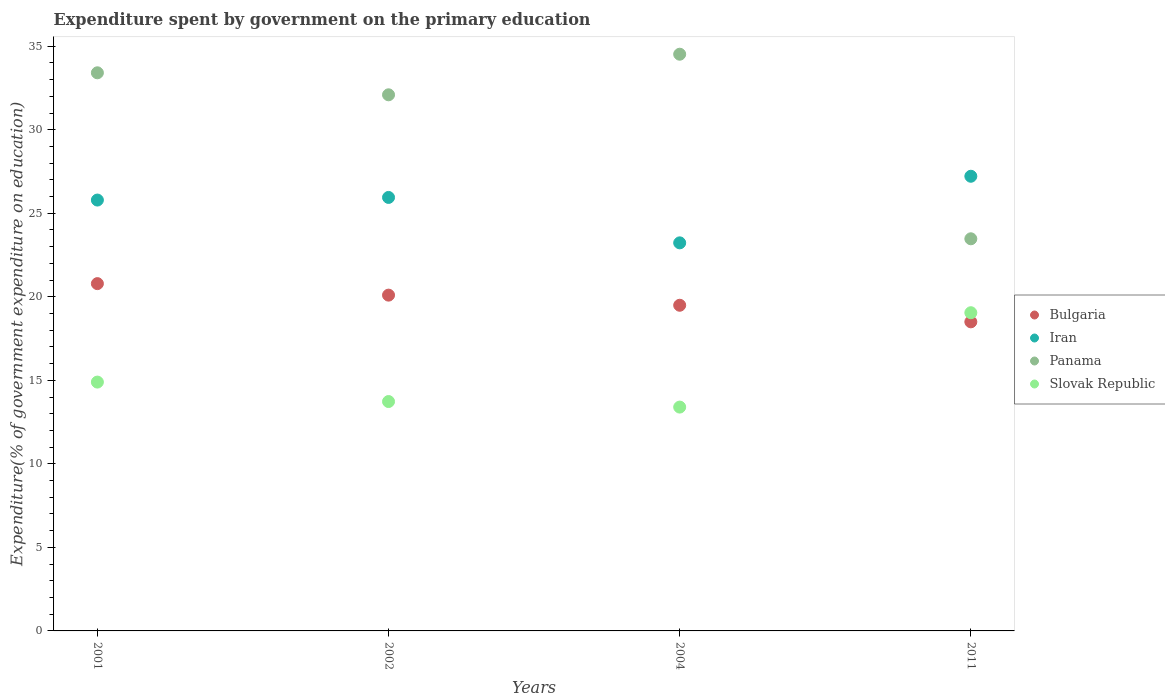How many different coloured dotlines are there?
Provide a succinct answer. 4. Is the number of dotlines equal to the number of legend labels?
Your response must be concise. Yes. What is the expenditure spent by government on the primary education in Panama in 2002?
Make the answer very short. 32.09. Across all years, what is the maximum expenditure spent by government on the primary education in Bulgaria?
Provide a short and direct response. 20.79. Across all years, what is the minimum expenditure spent by government on the primary education in Slovak Republic?
Your answer should be very brief. 13.4. In which year was the expenditure spent by government on the primary education in Panama maximum?
Offer a very short reply. 2004. What is the total expenditure spent by government on the primary education in Bulgaria in the graph?
Give a very brief answer. 78.88. What is the difference between the expenditure spent by government on the primary education in Panama in 2002 and that in 2004?
Make the answer very short. -2.43. What is the difference between the expenditure spent by government on the primary education in Panama in 2002 and the expenditure spent by government on the primary education in Iran in 2001?
Your response must be concise. 6.3. What is the average expenditure spent by government on the primary education in Bulgaria per year?
Offer a very short reply. 19.72. In the year 2002, what is the difference between the expenditure spent by government on the primary education in Panama and expenditure spent by government on the primary education in Bulgaria?
Keep it short and to the point. 11.99. What is the ratio of the expenditure spent by government on the primary education in Bulgaria in 2001 to that in 2011?
Offer a very short reply. 1.12. Is the expenditure spent by government on the primary education in Panama in 2004 less than that in 2011?
Your answer should be compact. No. What is the difference between the highest and the second highest expenditure spent by government on the primary education in Iran?
Provide a short and direct response. 1.27. What is the difference between the highest and the lowest expenditure spent by government on the primary education in Bulgaria?
Offer a terse response. 2.29. In how many years, is the expenditure spent by government on the primary education in Iran greater than the average expenditure spent by government on the primary education in Iran taken over all years?
Provide a succinct answer. 3. Is the sum of the expenditure spent by government on the primary education in Bulgaria in 2002 and 2004 greater than the maximum expenditure spent by government on the primary education in Iran across all years?
Your answer should be compact. Yes. Is it the case that in every year, the sum of the expenditure spent by government on the primary education in Slovak Republic and expenditure spent by government on the primary education in Bulgaria  is greater than the expenditure spent by government on the primary education in Panama?
Provide a succinct answer. No. Is the expenditure spent by government on the primary education in Iran strictly greater than the expenditure spent by government on the primary education in Bulgaria over the years?
Give a very brief answer. Yes. Is the expenditure spent by government on the primary education in Slovak Republic strictly less than the expenditure spent by government on the primary education in Panama over the years?
Ensure brevity in your answer.  Yes. How many dotlines are there?
Offer a terse response. 4. What is the difference between two consecutive major ticks on the Y-axis?
Offer a very short reply. 5. Does the graph contain any zero values?
Make the answer very short. No. Does the graph contain grids?
Provide a short and direct response. No. How many legend labels are there?
Provide a succinct answer. 4. How are the legend labels stacked?
Give a very brief answer. Vertical. What is the title of the graph?
Make the answer very short. Expenditure spent by government on the primary education. Does "St. Vincent and the Grenadines" appear as one of the legend labels in the graph?
Your answer should be compact. No. What is the label or title of the X-axis?
Offer a very short reply. Years. What is the label or title of the Y-axis?
Provide a succinct answer. Expenditure(% of government expenditure on education). What is the Expenditure(% of government expenditure on education) in Bulgaria in 2001?
Provide a succinct answer. 20.79. What is the Expenditure(% of government expenditure on education) in Iran in 2001?
Provide a short and direct response. 25.79. What is the Expenditure(% of government expenditure on education) of Panama in 2001?
Give a very brief answer. 33.41. What is the Expenditure(% of government expenditure on education) of Slovak Republic in 2001?
Make the answer very short. 14.89. What is the Expenditure(% of government expenditure on education) of Bulgaria in 2002?
Offer a terse response. 20.1. What is the Expenditure(% of government expenditure on education) in Iran in 2002?
Keep it short and to the point. 25.95. What is the Expenditure(% of government expenditure on education) of Panama in 2002?
Your answer should be very brief. 32.09. What is the Expenditure(% of government expenditure on education) in Slovak Republic in 2002?
Ensure brevity in your answer.  13.73. What is the Expenditure(% of government expenditure on education) of Bulgaria in 2004?
Give a very brief answer. 19.49. What is the Expenditure(% of government expenditure on education) of Iran in 2004?
Ensure brevity in your answer.  23.23. What is the Expenditure(% of government expenditure on education) of Panama in 2004?
Offer a terse response. 34.52. What is the Expenditure(% of government expenditure on education) in Slovak Republic in 2004?
Give a very brief answer. 13.4. What is the Expenditure(% of government expenditure on education) in Bulgaria in 2011?
Ensure brevity in your answer.  18.5. What is the Expenditure(% of government expenditure on education) of Iran in 2011?
Keep it short and to the point. 27.21. What is the Expenditure(% of government expenditure on education) of Panama in 2011?
Your answer should be very brief. 23.47. What is the Expenditure(% of government expenditure on education) of Slovak Republic in 2011?
Your response must be concise. 19.05. Across all years, what is the maximum Expenditure(% of government expenditure on education) of Bulgaria?
Give a very brief answer. 20.79. Across all years, what is the maximum Expenditure(% of government expenditure on education) in Iran?
Offer a very short reply. 27.21. Across all years, what is the maximum Expenditure(% of government expenditure on education) of Panama?
Make the answer very short. 34.52. Across all years, what is the maximum Expenditure(% of government expenditure on education) in Slovak Republic?
Keep it short and to the point. 19.05. Across all years, what is the minimum Expenditure(% of government expenditure on education) of Bulgaria?
Give a very brief answer. 18.5. Across all years, what is the minimum Expenditure(% of government expenditure on education) in Iran?
Give a very brief answer. 23.23. Across all years, what is the minimum Expenditure(% of government expenditure on education) of Panama?
Provide a short and direct response. 23.47. Across all years, what is the minimum Expenditure(% of government expenditure on education) in Slovak Republic?
Offer a terse response. 13.4. What is the total Expenditure(% of government expenditure on education) of Bulgaria in the graph?
Your answer should be compact. 78.88. What is the total Expenditure(% of government expenditure on education) of Iran in the graph?
Offer a terse response. 102.18. What is the total Expenditure(% of government expenditure on education) of Panama in the graph?
Offer a terse response. 123.49. What is the total Expenditure(% of government expenditure on education) in Slovak Republic in the graph?
Offer a very short reply. 61.07. What is the difference between the Expenditure(% of government expenditure on education) of Bulgaria in 2001 and that in 2002?
Provide a short and direct response. 0.69. What is the difference between the Expenditure(% of government expenditure on education) in Iran in 2001 and that in 2002?
Offer a very short reply. -0.16. What is the difference between the Expenditure(% of government expenditure on education) of Panama in 2001 and that in 2002?
Provide a short and direct response. 1.32. What is the difference between the Expenditure(% of government expenditure on education) of Slovak Republic in 2001 and that in 2002?
Your answer should be compact. 1.16. What is the difference between the Expenditure(% of government expenditure on education) in Bulgaria in 2001 and that in 2004?
Give a very brief answer. 1.29. What is the difference between the Expenditure(% of government expenditure on education) in Iran in 2001 and that in 2004?
Keep it short and to the point. 2.56. What is the difference between the Expenditure(% of government expenditure on education) of Panama in 2001 and that in 2004?
Your answer should be very brief. -1.11. What is the difference between the Expenditure(% of government expenditure on education) of Slovak Republic in 2001 and that in 2004?
Make the answer very short. 1.5. What is the difference between the Expenditure(% of government expenditure on education) of Bulgaria in 2001 and that in 2011?
Provide a short and direct response. 2.29. What is the difference between the Expenditure(% of government expenditure on education) in Iran in 2001 and that in 2011?
Your answer should be compact. -1.42. What is the difference between the Expenditure(% of government expenditure on education) of Panama in 2001 and that in 2011?
Ensure brevity in your answer.  9.94. What is the difference between the Expenditure(% of government expenditure on education) in Slovak Republic in 2001 and that in 2011?
Keep it short and to the point. -4.15. What is the difference between the Expenditure(% of government expenditure on education) of Bulgaria in 2002 and that in 2004?
Your answer should be compact. 0.61. What is the difference between the Expenditure(% of government expenditure on education) of Iran in 2002 and that in 2004?
Your response must be concise. 2.72. What is the difference between the Expenditure(% of government expenditure on education) in Panama in 2002 and that in 2004?
Provide a succinct answer. -2.43. What is the difference between the Expenditure(% of government expenditure on education) of Slovak Republic in 2002 and that in 2004?
Provide a short and direct response. 0.33. What is the difference between the Expenditure(% of government expenditure on education) of Bulgaria in 2002 and that in 2011?
Offer a very short reply. 1.6. What is the difference between the Expenditure(% of government expenditure on education) in Iran in 2002 and that in 2011?
Make the answer very short. -1.27. What is the difference between the Expenditure(% of government expenditure on education) of Panama in 2002 and that in 2011?
Your answer should be very brief. 8.62. What is the difference between the Expenditure(% of government expenditure on education) in Slovak Republic in 2002 and that in 2011?
Offer a terse response. -5.32. What is the difference between the Expenditure(% of government expenditure on education) of Iran in 2004 and that in 2011?
Make the answer very short. -3.99. What is the difference between the Expenditure(% of government expenditure on education) of Panama in 2004 and that in 2011?
Provide a succinct answer. 11.05. What is the difference between the Expenditure(% of government expenditure on education) in Slovak Republic in 2004 and that in 2011?
Make the answer very short. -5.65. What is the difference between the Expenditure(% of government expenditure on education) of Bulgaria in 2001 and the Expenditure(% of government expenditure on education) of Iran in 2002?
Offer a terse response. -5.16. What is the difference between the Expenditure(% of government expenditure on education) in Bulgaria in 2001 and the Expenditure(% of government expenditure on education) in Panama in 2002?
Give a very brief answer. -11.3. What is the difference between the Expenditure(% of government expenditure on education) of Bulgaria in 2001 and the Expenditure(% of government expenditure on education) of Slovak Republic in 2002?
Keep it short and to the point. 7.06. What is the difference between the Expenditure(% of government expenditure on education) of Iran in 2001 and the Expenditure(% of government expenditure on education) of Panama in 2002?
Your response must be concise. -6.3. What is the difference between the Expenditure(% of government expenditure on education) in Iran in 2001 and the Expenditure(% of government expenditure on education) in Slovak Republic in 2002?
Your answer should be very brief. 12.06. What is the difference between the Expenditure(% of government expenditure on education) of Panama in 2001 and the Expenditure(% of government expenditure on education) of Slovak Republic in 2002?
Ensure brevity in your answer.  19.68. What is the difference between the Expenditure(% of government expenditure on education) in Bulgaria in 2001 and the Expenditure(% of government expenditure on education) in Iran in 2004?
Provide a succinct answer. -2.44. What is the difference between the Expenditure(% of government expenditure on education) of Bulgaria in 2001 and the Expenditure(% of government expenditure on education) of Panama in 2004?
Keep it short and to the point. -13.73. What is the difference between the Expenditure(% of government expenditure on education) in Bulgaria in 2001 and the Expenditure(% of government expenditure on education) in Slovak Republic in 2004?
Offer a terse response. 7.39. What is the difference between the Expenditure(% of government expenditure on education) in Iran in 2001 and the Expenditure(% of government expenditure on education) in Panama in 2004?
Provide a succinct answer. -8.73. What is the difference between the Expenditure(% of government expenditure on education) of Iran in 2001 and the Expenditure(% of government expenditure on education) of Slovak Republic in 2004?
Offer a terse response. 12.39. What is the difference between the Expenditure(% of government expenditure on education) in Panama in 2001 and the Expenditure(% of government expenditure on education) in Slovak Republic in 2004?
Your answer should be very brief. 20.01. What is the difference between the Expenditure(% of government expenditure on education) of Bulgaria in 2001 and the Expenditure(% of government expenditure on education) of Iran in 2011?
Make the answer very short. -6.43. What is the difference between the Expenditure(% of government expenditure on education) of Bulgaria in 2001 and the Expenditure(% of government expenditure on education) of Panama in 2011?
Your response must be concise. -2.68. What is the difference between the Expenditure(% of government expenditure on education) of Bulgaria in 2001 and the Expenditure(% of government expenditure on education) of Slovak Republic in 2011?
Provide a succinct answer. 1.74. What is the difference between the Expenditure(% of government expenditure on education) of Iran in 2001 and the Expenditure(% of government expenditure on education) of Panama in 2011?
Offer a terse response. 2.32. What is the difference between the Expenditure(% of government expenditure on education) in Iran in 2001 and the Expenditure(% of government expenditure on education) in Slovak Republic in 2011?
Ensure brevity in your answer.  6.74. What is the difference between the Expenditure(% of government expenditure on education) in Panama in 2001 and the Expenditure(% of government expenditure on education) in Slovak Republic in 2011?
Give a very brief answer. 14.36. What is the difference between the Expenditure(% of government expenditure on education) in Bulgaria in 2002 and the Expenditure(% of government expenditure on education) in Iran in 2004?
Provide a short and direct response. -3.13. What is the difference between the Expenditure(% of government expenditure on education) of Bulgaria in 2002 and the Expenditure(% of government expenditure on education) of Panama in 2004?
Offer a terse response. -14.42. What is the difference between the Expenditure(% of government expenditure on education) of Bulgaria in 2002 and the Expenditure(% of government expenditure on education) of Slovak Republic in 2004?
Keep it short and to the point. 6.7. What is the difference between the Expenditure(% of government expenditure on education) of Iran in 2002 and the Expenditure(% of government expenditure on education) of Panama in 2004?
Your response must be concise. -8.57. What is the difference between the Expenditure(% of government expenditure on education) of Iran in 2002 and the Expenditure(% of government expenditure on education) of Slovak Republic in 2004?
Your answer should be very brief. 12.55. What is the difference between the Expenditure(% of government expenditure on education) of Panama in 2002 and the Expenditure(% of government expenditure on education) of Slovak Republic in 2004?
Provide a succinct answer. 18.69. What is the difference between the Expenditure(% of government expenditure on education) of Bulgaria in 2002 and the Expenditure(% of government expenditure on education) of Iran in 2011?
Your answer should be very brief. -7.12. What is the difference between the Expenditure(% of government expenditure on education) in Bulgaria in 2002 and the Expenditure(% of government expenditure on education) in Panama in 2011?
Your answer should be very brief. -3.37. What is the difference between the Expenditure(% of government expenditure on education) of Bulgaria in 2002 and the Expenditure(% of government expenditure on education) of Slovak Republic in 2011?
Provide a short and direct response. 1.05. What is the difference between the Expenditure(% of government expenditure on education) of Iran in 2002 and the Expenditure(% of government expenditure on education) of Panama in 2011?
Ensure brevity in your answer.  2.48. What is the difference between the Expenditure(% of government expenditure on education) in Iran in 2002 and the Expenditure(% of government expenditure on education) in Slovak Republic in 2011?
Offer a very short reply. 6.9. What is the difference between the Expenditure(% of government expenditure on education) of Panama in 2002 and the Expenditure(% of government expenditure on education) of Slovak Republic in 2011?
Offer a terse response. 13.04. What is the difference between the Expenditure(% of government expenditure on education) of Bulgaria in 2004 and the Expenditure(% of government expenditure on education) of Iran in 2011?
Provide a succinct answer. -7.72. What is the difference between the Expenditure(% of government expenditure on education) of Bulgaria in 2004 and the Expenditure(% of government expenditure on education) of Panama in 2011?
Offer a very short reply. -3.98. What is the difference between the Expenditure(% of government expenditure on education) of Bulgaria in 2004 and the Expenditure(% of government expenditure on education) of Slovak Republic in 2011?
Ensure brevity in your answer.  0.45. What is the difference between the Expenditure(% of government expenditure on education) of Iran in 2004 and the Expenditure(% of government expenditure on education) of Panama in 2011?
Offer a terse response. -0.24. What is the difference between the Expenditure(% of government expenditure on education) in Iran in 2004 and the Expenditure(% of government expenditure on education) in Slovak Republic in 2011?
Ensure brevity in your answer.  4.18. What is the difference between the Expenditure(% of government expenditure on education) in Panama in 2004 and the Expenditure(% of government expenditure on education) in Slovak Republic in 2011?
Give a very brief answer. 15.47. What is the average Expenditure(% of government expenditure on education) in Bulgaria per year?
Keep it short and to the point. 19.72. What is the average Expenditure(% of government expenditure on education) of Iran per year?
Make the answer very short. 25.54. What is the average Expenditure(% of government expenditure on education) in Panama per year?
Ensure brevity in your answer.  30.87. What is the average Expenditure(% of government expenditure on education) in Slovak Republic per year?
Give a very brief answer. 15.27. In the year 2001, what is the difference between the Expenditure(% of government expenditure on education) in Bulgaria and Expenditure(% of government expenditure on education) in Iran?
Provide a short and direct response. -5. In the year 2001, what is the difference between the Expenditure(% of government expenditure on education) in Bulgaria and Expenditure(% of government expenditure on education) in Panama?
Offer a terse response. -12.62. In the year 2001, what is the difference between the Expenditure(% of government expenditure on education) of Bulgaria and Expenditure(% of government expenditure on education) of Slovak Republic?
Your response must be concise. 5.89. In the year 2001, what is the difference between the Expenditure(% of government expenditure on education) of Iran and Expenditure(% of government expenditure on education) of Panama?
Provide a short and direct response. -7.62. In the year 2001, what is the difference between the Expenditure(% of government expenditure on education) in Iran and Expenditure(% of government expenditure on education) in Slovak Republic?
Your answer should be compact. 10.9. In the year 2001, what is the difference between the Expenditure(% of government expenditure on education) in Panama and Expenditure(% of government expenditure on education) in Slovak Republic?
Your answer should be very brief. 18.51. In the year 2002, what is the difference between the Expenditure(% of government expenditure on education) of Bulgaria and Expenditure(% of government expenditure on education) of Iran?
Provide a short and direct response. -5.85. In the year 2002, what is the difference between the Expenditure(% of government expenditure on education) in Bulgaria and Expenditure(% of government expenditure on education) in Panama?
Your response must be concise. -11.99. In the year 2002, what is the difference between the Expenditure(% of government expenditure on education) in Bulgaria and Expenditure(% of government expenditure on education) in Slovak Republic?
Offer a very short reply. 6.37. In the year 2002, what is the difference between the Expenditure(% of government expenditure on education) of Iran and Expenditure(% of government expenditure on education) of Panama?
Keep it short and to the point. -6.14. In the year 2002, what is the difference between the Expenditure(% of government expenditure on education) of Iran and Expenditure(% of government expenditure on education) of Slovak Republic?
Offer a very short reply. 12.22. In the year 2002, what is the difference between the Expenditure(% of government expenditure on education) in Panama and Expenditure(% of government expenditure on education) in Slovak Republic?
Make the answer very short. 18.36. In the year 2004, what is the difference between the Expenditure(% of government expenditure on education) in Bulgaria and Expenditure(% of government expenditure on education) in Iran?
Offer a very short reply. -3.74. In the year 2004, what is the difference between the Expenditure(% of government expenditure on education) in Bulgaria and Expenditure(% of government expenditure on education) in Panama?
Your answer should be very brief. -15.03. In the year 2004, what is the difference between the Expenditure(% of government expenditure on education) in Bulgaria and Expenditure(% of government expenditure on education) in Slovak Republic?
Your answer should be very brief. 6.09. In the year 2004, what is the difference between the Expenditure(% of government expenditure on education) of Iran and Expenditure(% of government expenditure on education) of Panama?
Offer a very short reply. -11.29. In the year 2004, what is the difference between the Expenditure(% of government expenditure on education) in Iran and Expenditure(% of government expenditure on education) in Slovak Republic?
Your answer should be compact. 9.83. In the year 2004, what is the difference between the Expenditure(% of government expenditure on education) in Panama and Expenditure(% of government expenditure on education) in Slovak Republic?
Your answer should be very brief. 21.12. In the year 2011, what is the difference between the Expenditure(% of government expenditure on education) in Bulgaria and Expenditure(% of government expenditure on education) in Iran?
Provide a succinct answer. -8.71. In the year 2011, what is the difference between the Expenditure(% of government expenditure on education) in Bulgaria and Expenditure(% of government expenditure on education) in Panama?
Your answer should be compact. -4.97. In the year 2011, what is the difference between the Expenditure(% of government expenditure on education) in Bulgaria and Expenditure(% of government expenditure on education) in Slovak Republic?
Make the answer very short. -0.55. In the year 2011, what is the difference between the Expenditure(% of government expenditure on education) in Iran and Expenditure(% of government expenditure on education) in Panama?
Provide a succinct answer. 3.74. In the year 2011, what is the difference between the Expenditure(% of government expenditure on education) of Iran and Expenditure(% of government expenditure on education) of Slovak Republic?
Offer a very short reply. 8.17. In the year 2011, what is the difference between the Expenditure(% of government expenditure on education) in Panama and Expenditure(% of government expenditure on education) in Slovak Republic?
Your answer should be very brief. 4.43. What is the ratio of the Expenditure(% of government expenditure on education) in Bulgaria in 2001 to that in 2002?
Your answer should be very brief. 1.03. What is the ratio of the Expenditure(% of government expenditure on education) in Iran in 2001 to that in 2002?
Your response must be concise. 0.99. What is the ratio of the Expenditure(% of government expenditure on education) of Panama in 2001 to that in 2002?
Keep it short and to the point. 1.04. What is the ratio of the Expenditure(% of government expenditure on education) of Slovak Republic in 2001 to that in 2002?
Your response must be concise. 1.08. What is the ratio of the Expenditure(% of government expenditure on education) in Bulgaria in 2001 to that in 2004?
Make the answer very short. 1.07. What is the ratio of the Expenditure(% of government expenditure on education) in Iran in 2001 to that in 2004?
Provide a succinct answer. 1.11. What is the ratio of the Expenditure(% of government expenditure on education) of Panama in 2001 to that in 2004?
Offer a very short reply. 0.97. What is the ratio of the Expenditure(% of government expenditure on education) of Slovak Republic in 2001 to that in 2004?
Ensure brevity in your answer.  1.11. What is the ratio of the Expenditure(% of government expenditure on education) in Bulgaria in 2001 to that in 2011?
Provide a short and direct response. 1.12. What is the ratio of the Expenditure(% of government expenditure on education) of Iran in 2001 to that in 2011?
Your answer should be very brief. 0.95. What is the ratio of the Expenditure(% of government expenditure on education) of Panama in 2001 to that in 2011?
Provide a succinct answer. 1.42. What is the ratio of the Expenditure(% of government expenditure on education) of Slovak Republic in 2001 to that in 2011?
Offer a very short reply. 0.78. What is the ratio of the Expenditure(% of government expenditure on education) in Bulgaria in 2002 to that in 2004?
Ensure brevity in your answer.  1.03. What is the ratio of the Expenditure(% of government expenditure on education) in Iran in 2002 to that in 2004?
Provide a succinct answer. 1.12. What is the ratio of the Expenditure(% of government expenditure on education) of Panama in 2002 to that in 2004?
Offer a terse response. 0.93. What is the ratio of the Expenditure(% of government expenditure on education) of Slovak Republic in 2002 to that in 2004?
Ensure brevity in your answer.  1.02. What is the ratio of the Expenditure(% of government expenditure on education) in Bulgaria in 2002 to that in 2011?
Your answer should be compact. 1.09. What is the ratio of the Expenditure(% of government expenditure on education) of Iran in 2002 to that in 2011?
Your answer should be compact. 0.95. What is the ratio of the Expenditure(% of government expenditure on education) of Panama in 2002 to that in 2011?
Ensure brevity in your answer.  1.37. What is the ratio of the Expenditure(% of government expenditure on education) of Slovak Republic in 2002 to that in 2011?
Your answer should be compact. 0.72. What is the ratio of the Expenditure(% of government expenditure on education) of Bulgaria in 2004 to that in 2011?
Offer a very short reply. 1.05. What is the ratio of the Expenditure(% of government expenditure on education) of Iran in 2004 to that in 2011?
Offer a terse response. 0.85. What is the ratio of the Expenditure(% of government expenditure on education) of Panama in 2004 to that in 2011?
Give a very brief answer. 1.47. What is the ratio of the Expenditure(% of government expenditure on education) of Slovak Republic in 2004 to that in 2011?
Keep it short and to the point. 0.7. What is the difference between the highest and the second highest Expenditure(% of government expenditure on education) in Bulgaria?
Offer a terse response. 0.69. What is the difference between the highest and the second highest Expenditure(% of government expenditure on education) of Iran?
Your response must be concise. 1.27. What is the difference between the highest and the second highest Expenditure(% of government expenditure on education) of Panama?
Offer a terse response. 1.11. What is the difference between the highest and the second highest Expenditure(% of government expenditure on education) in Slovak Republic?
Provide a short and direct response. 4.15. What is the difference between the highest and the lowest Expenditure(% of government expenditure on education) of Bulgaria?
Make the answer very short. 2.29. What is the difference between the highest and the lowest Expenditure(% of government expenditure on education) in Iran?
Keep it short and to the point. 3.99. What is the difference between the highest and the lowest Expenditure(% of government expenditure on education) in Panama?
Keep it short and to the point. 11.05. What is the difference between the highest and the lowest Expenditure(% of government expenditure on education) of Slovak Republic?
Provide a succinct answer. 5.65. 